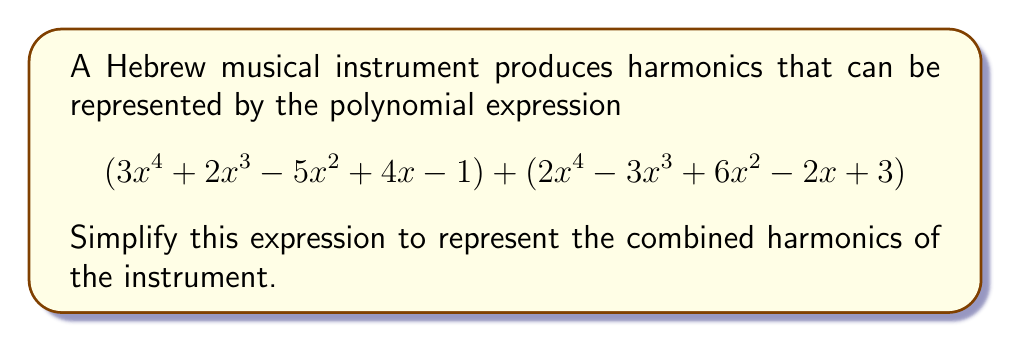Could you help me with this problem? To simplify this polynomial expression, we need to combine like terms:

1) First, let's group like terms together:
   $$(3x^4 + 2x^4) + (2x^3 - 3x^3) + (-5x^2 + 6x^2) + (4x - 2x) + (-1 + 3)$$

2) Now, let's perform the addition or subtraction for each group:

   a) $x^4$ terms: $3x^4 + 2x^4 = 5x^4$
   b) $x^3$ terms: $2x^3 - 3x^3 = -x^3$
   c) $x^2$ terms: $-5x^2 + 6x^2 = x^2$
   d) $x$ terms: $4x - 2x = 2x$
   e) Constant terms: $-1 + 3 = 2$

3) Finally, we can write our simplified polynomial:

   $$5x^4 - x^3 + x^2 + 2x + 2$$

This simplified polynomial represents the combined harmonics of the Hebrew musical instrument.
Answer: $$5x^4 - x^3 + x^2 + 2x + 2$$ 